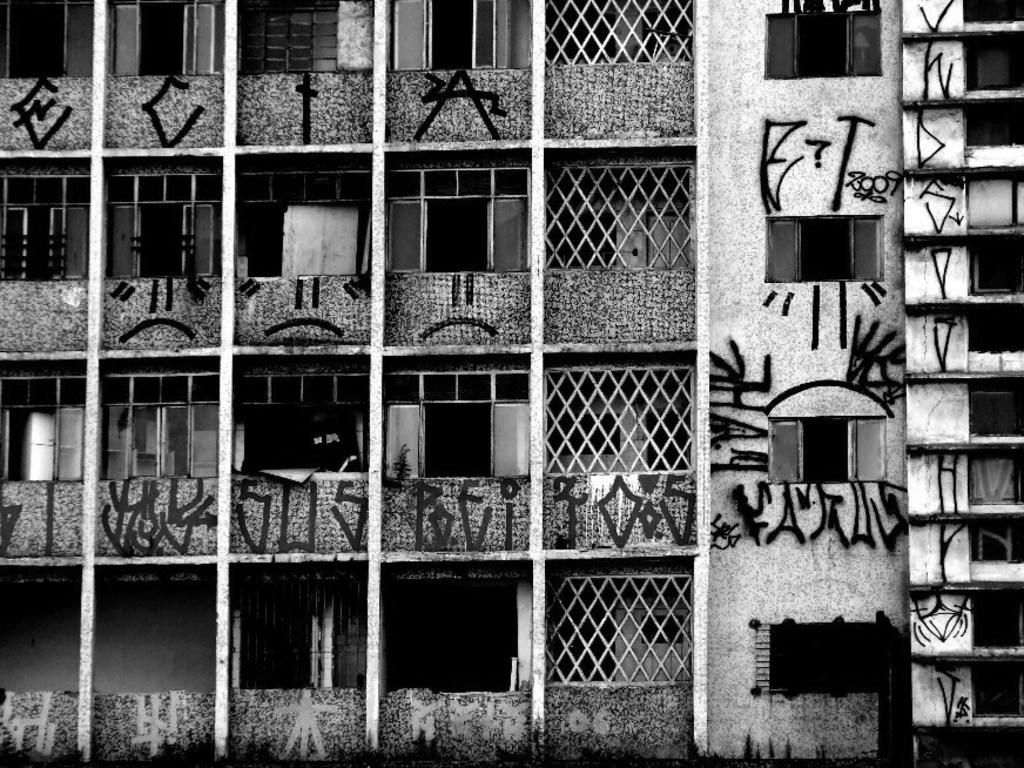Describe this image in one or two sentences. In this image I can see buildings, windows, doors, fence and paintings on a wall. This image is taken may be in the evening. 